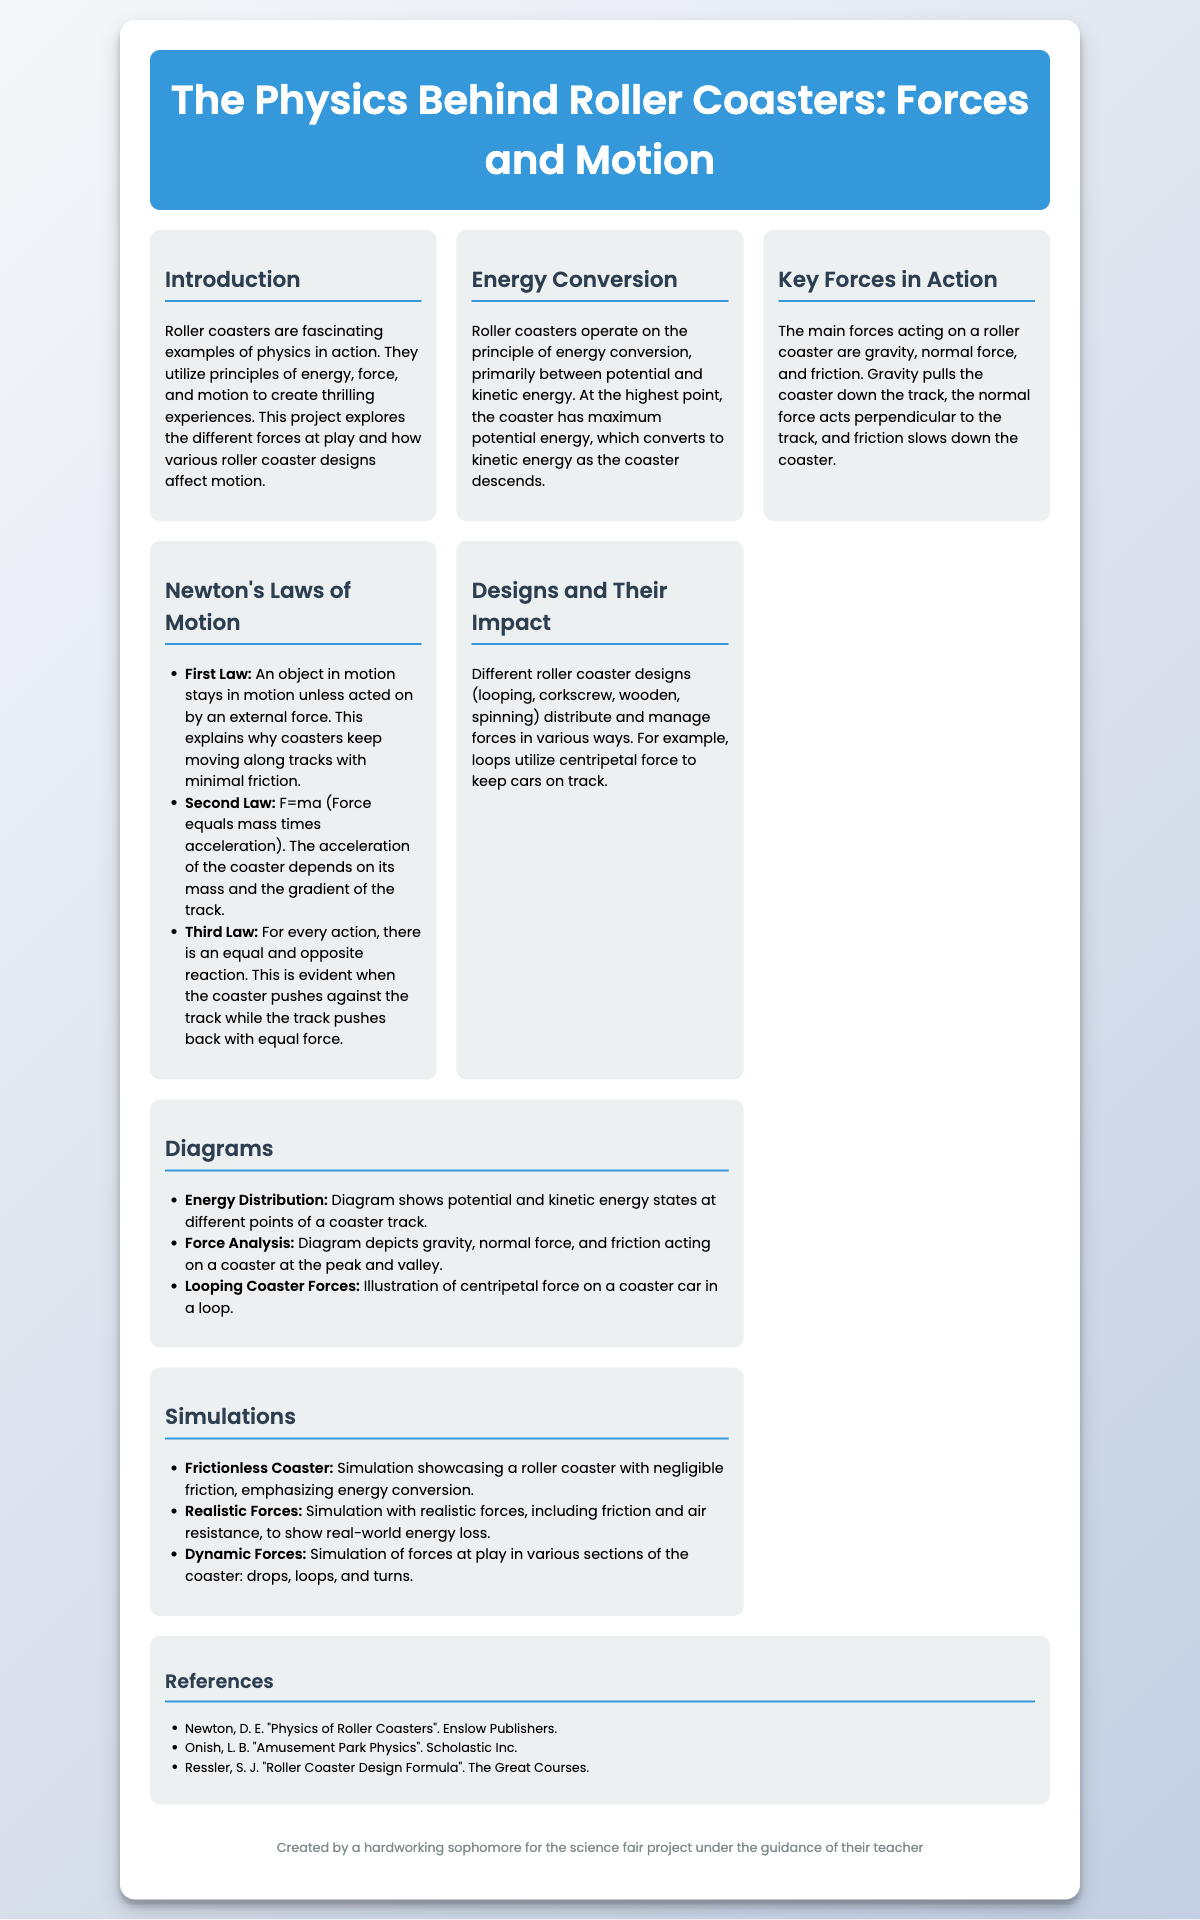what is the title of the poster? The title of the poster is prominently displayed in the header section.
Answer: The Physics Behind Roller Coasters: Forces and Motion what are the key forces acting on a roller coaster? The key forces are outlined in the section about key forces in action.
Answer: Gravity, normal force, and friction what is the first law of motion according to the document? The first law is listed in the Newton's Laws of Motion section.
Answer: An object in motion stays in motion unless acted on by an external force what type of energy is at its maximum at the highest point of a coaster? The introduction discusses energy states in roller coasters.
Answer: Potential energy how many simulations are featured in the poster? The number of simulations is indicated in the simulations section.
Answer: Three what design utilizes centripetal force? This is mentioned in the designs and their impact section of the poster.
Answer: Looping what is the main focus of the introduction? The introduction provides an overview of the key concepts explored in the poster.
Answer: Forces at play and roller coaster designs who is the poster created by? The footer section specifies the creator of the poster.
Answer: A hardworking sophomore what is the purpose of the diagrams section? The purpose is explained in the context of the diagrams within the poster.
Answer: To show energy and force interactions 